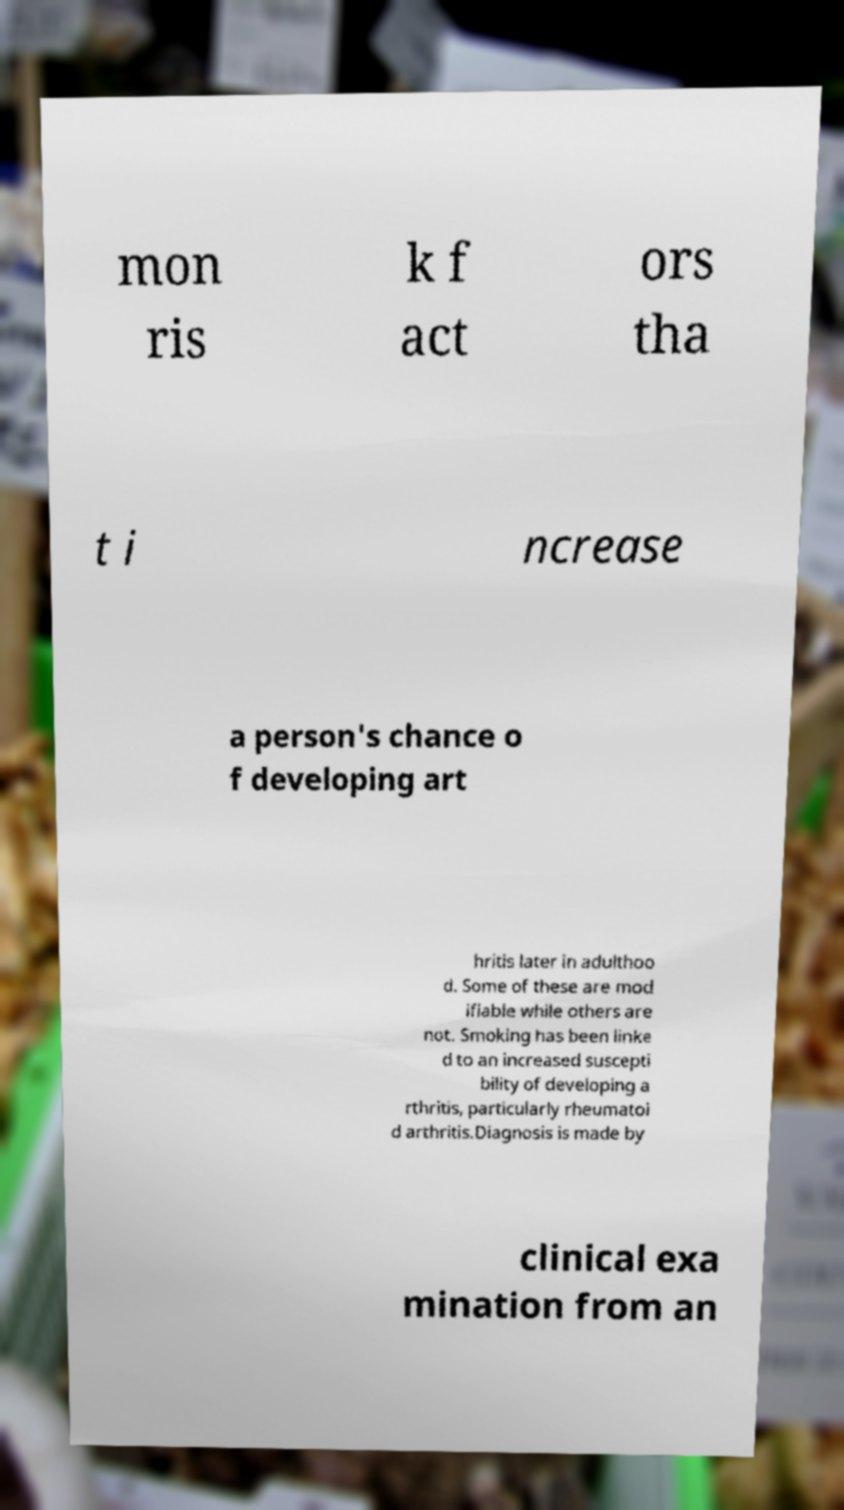What messages or text are displayed in this image? I need them in a readable, typed format. mon ris k f act ors tha t i ncrease a person's chance o f developing art hritis later in adulthoo d. Some of these are mod ifiable while others are not. Smoking has been linke d to an increased suscepti bility of developing a rthritis, particularly rheumatoi d arthritis.Diagnosis is made by clinical exa mination from an 